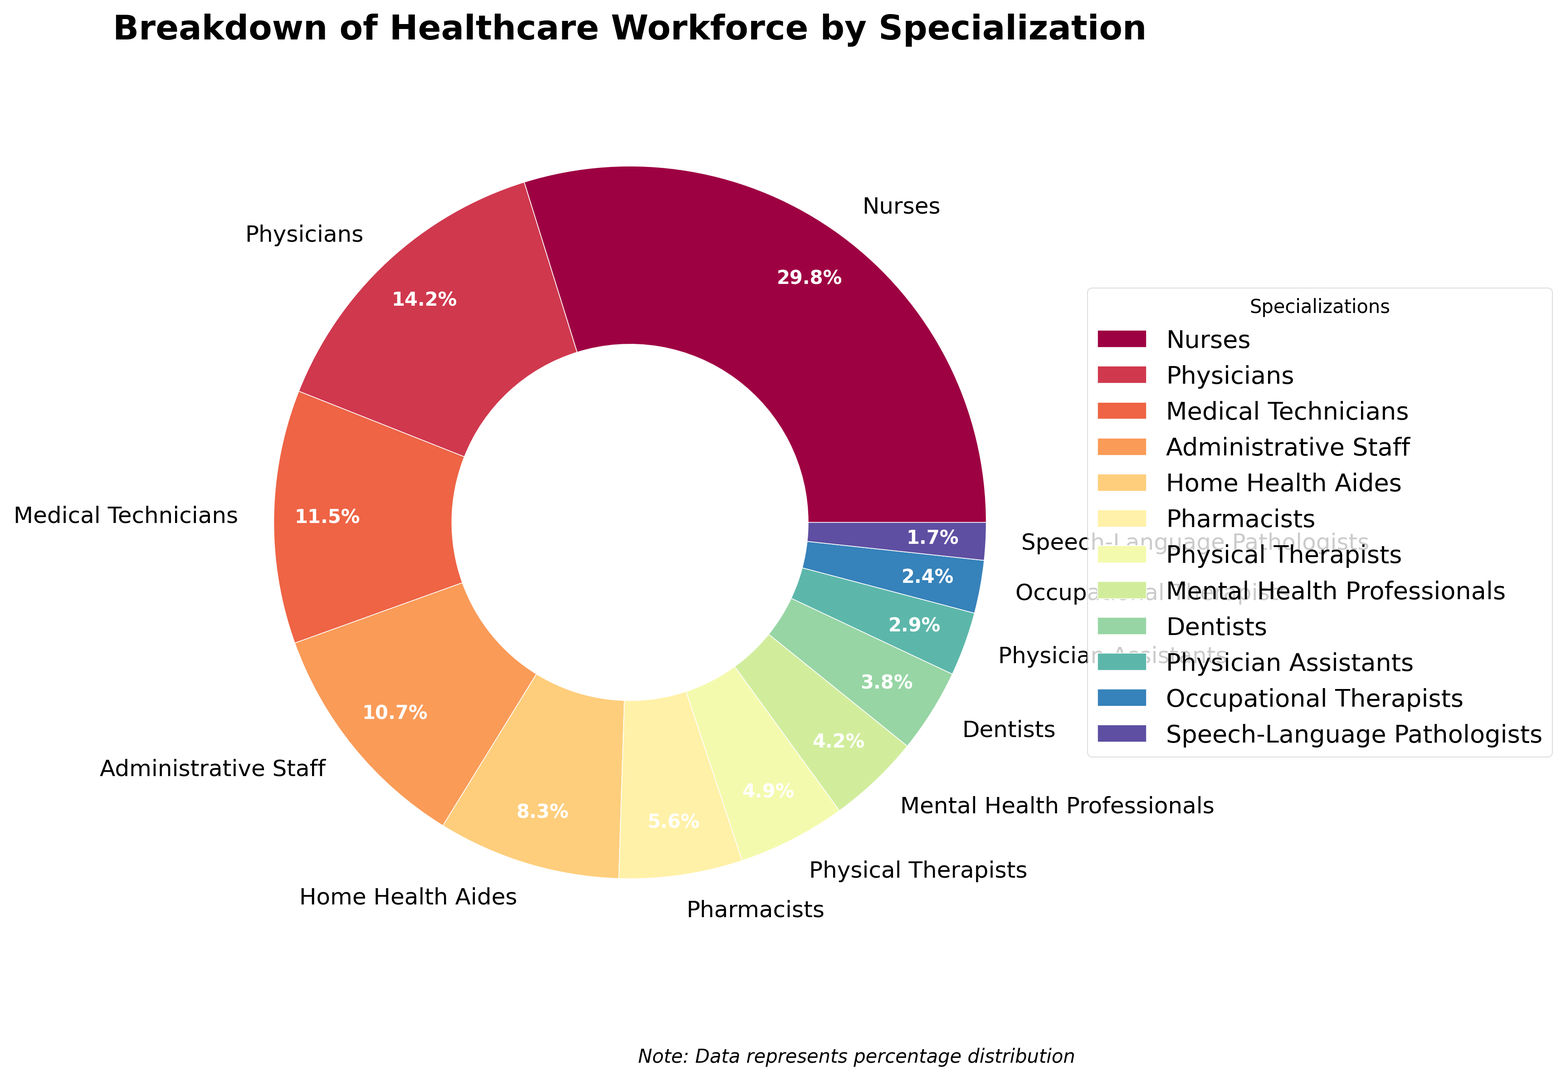Which specialization has the highest percentage in the healthcare workforce? The pie chart shows that "Nurses" has the largest slice. By directly looking at the label on the pie corresponding to "Nurses," one can see it represents 29.8%. Therefore, the specialization with the highest percentage is "Nurses".
Answer: Nurses Which specialization has the lowest percentage in the healthcare workforce? By checking the smallest slice in the pie chart, "Speech-Language Pathologists" represents the smallest portion with its label indicating 1.7%. Therefore, the specialization with the lowest percentage is "Speech-Language Pathologists".
Answer: Speech-Language Pathologists How much larger is the percentage of Nurses compared to Physicians? According to the pie chart, the percentage for Nurses is 29.8% and for Physicians is 14.2%. Subtracting these values: 29.8% - 14.2% gives the difference.
Answer: 15.6% What is the total percentage of the workforce made up of Administrative Staff, Pharmacists, and Physical Therapists combined? Looking at the labels for these specializations: Administrative Staff (10.7%), Pharmacists (5.6%), and Physical Therapists (4.9%). The sum is 10.7% + 5.6% + 4.9%.
Answer: 21.2% How does the percentage of Medical Technicians compare to Home Health Aides? The percentage for Medical Technicians is 11.5%, while for Home Health Aides it is 8.3%. Here we see that Medical Technicians have a higher percentage.
Answer: Medical Technicians have a higher percentage Which is greater: the combined percentage of Pharmacists, Physical Therapists, and Mental Health Professionals or the percentage of Nurses? Summing up the percentages for Pharmacists (5.6%), Physical Therapists (4.9%), and Mental Health Professionals (4.2%) gives 5.6% + 4.9% + 4.2% = 14.7%. The percentage for Nurses is 29.8%. Comparing 14.7% to 29.8%, Nurses have the greater percentage.
Answer: Nurses What percent of the healthcare workforce is represented by all the remaining specializations excluding Nurses and Physicians? Summing the percentages for all specializations except Nurses (29.8%) and Physicians (14.2%): 11.5% + 10.7% + 8.3% + 5.6% + 4.9% + 4.2% + 3.8% + 2.9% + 2.4% + 1.7%. The total thus is 56%.
Answer: 56% What is the ratio of the percentage of Speech-Language Pathologists to that of Dentists? The percentage for Speech-Language Pathologists is 1.7% and for Dentists is 3.8%. The ratio is calculated as 1.7 / 3.8.
Answer: 0.45 Which specializations make up more than 10% of the healthcare workforce? By examining the slices of the pie chart, we identify the ones labeled with more than 10%: Nurses (29.8%), and Physicians (14.2%), Medical Technicians (11.5%), and Administrative Staff (10.7%).
Answer: Nurses, Physicians, Medical Technicians, and Administrative Staff 